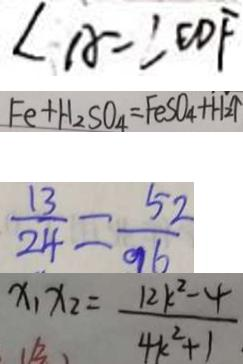Convert formula to latex. <formula><loc_0><loc_0><loc_500><loc_500>\angle A = \angle E D F 
 F e + H _ { 2 } S O _ { 4 } = F e S O _ { 4 } + H _ { 2 } \uparrow 
 \frac { 1 3 } { 2 4 } = \frac { 5 2 } { 9 6 } 
 x _ { 1 } x _ { 2 } = \frac { 1 2 k ^ { 2 } - 4 } { 4 k ^ { 2 } + 1 }</formula> 